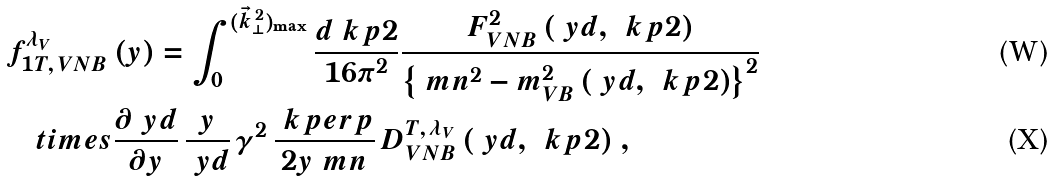<formula> <loc_0><loc_0><loc_500><loc_500>& f ^ { \lambda _ { V } } _ { 1 T , \, V N B } \, ( y ) = \int _ { 0 } ^ { ( \vec { k } _ { \perp } ^ { \, 2 } ) _ { \max } } \frac { d \ k p 2 } { 1 6 \pi ^ { 2 } } \frac { F ^ { 2 } _ { V N B } \, ( \ y d , \, \ k p 2 ) } { \left \{ \ m n ^ { 2 } - m _ { V B } ^ { 2 } \, ( \ y d , \, \ k p 2 ) \right \} ^ { 2 } } \\ & \quad t i m e s \frac { \partial \ y d } { \partial y } \, \frac { y } { \ y d } \, \gamma ^ { 2 } \, \frac { \ k p e r p } { 2 y \ m n } \, D ^ { T , \, \lambda _ { V } } _ { V N B } \, ( \ y d , \, \ k p 2 ) \ ,</formula> 